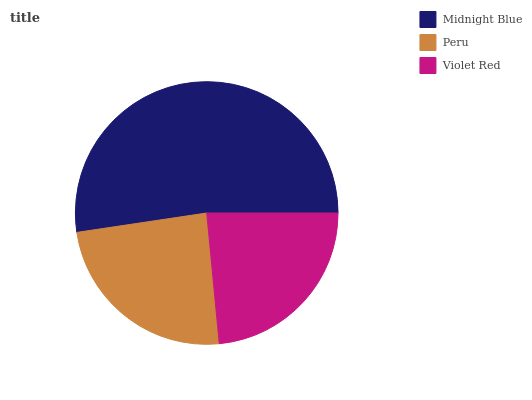Is Violet Red the minimum?
Answer yes or no. Yes. Is Midnight Blue the maximum?
Answer yes or no. Yes. Is Peru the minimum?
Answer yes or no. No. Is Peru the maximum?
Answer yes or no. No. Is Midnight Blue greater than Peru?
Answer yes or no. Yes. Is Peru less than Midnight Blue?
Answer yes or no. Yes. Is Peru greater than Midnight Blue?
Answer yes or no. No. Is Midnight Blue less than Peru?
Answer yes or no. No. Is Peru the high median?
Answer yes or no. Yes. Is Peru the low median?
Answer yes or no. Yes. Is Midnight Blue the high median?
Answer yes or no. No. Is Violet Red the low median?
Answer yes or no. No. 